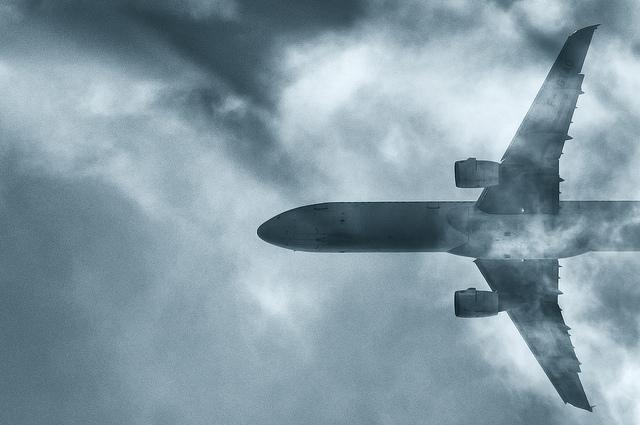How many engines do you see?
Give a very brief answer. 2. 